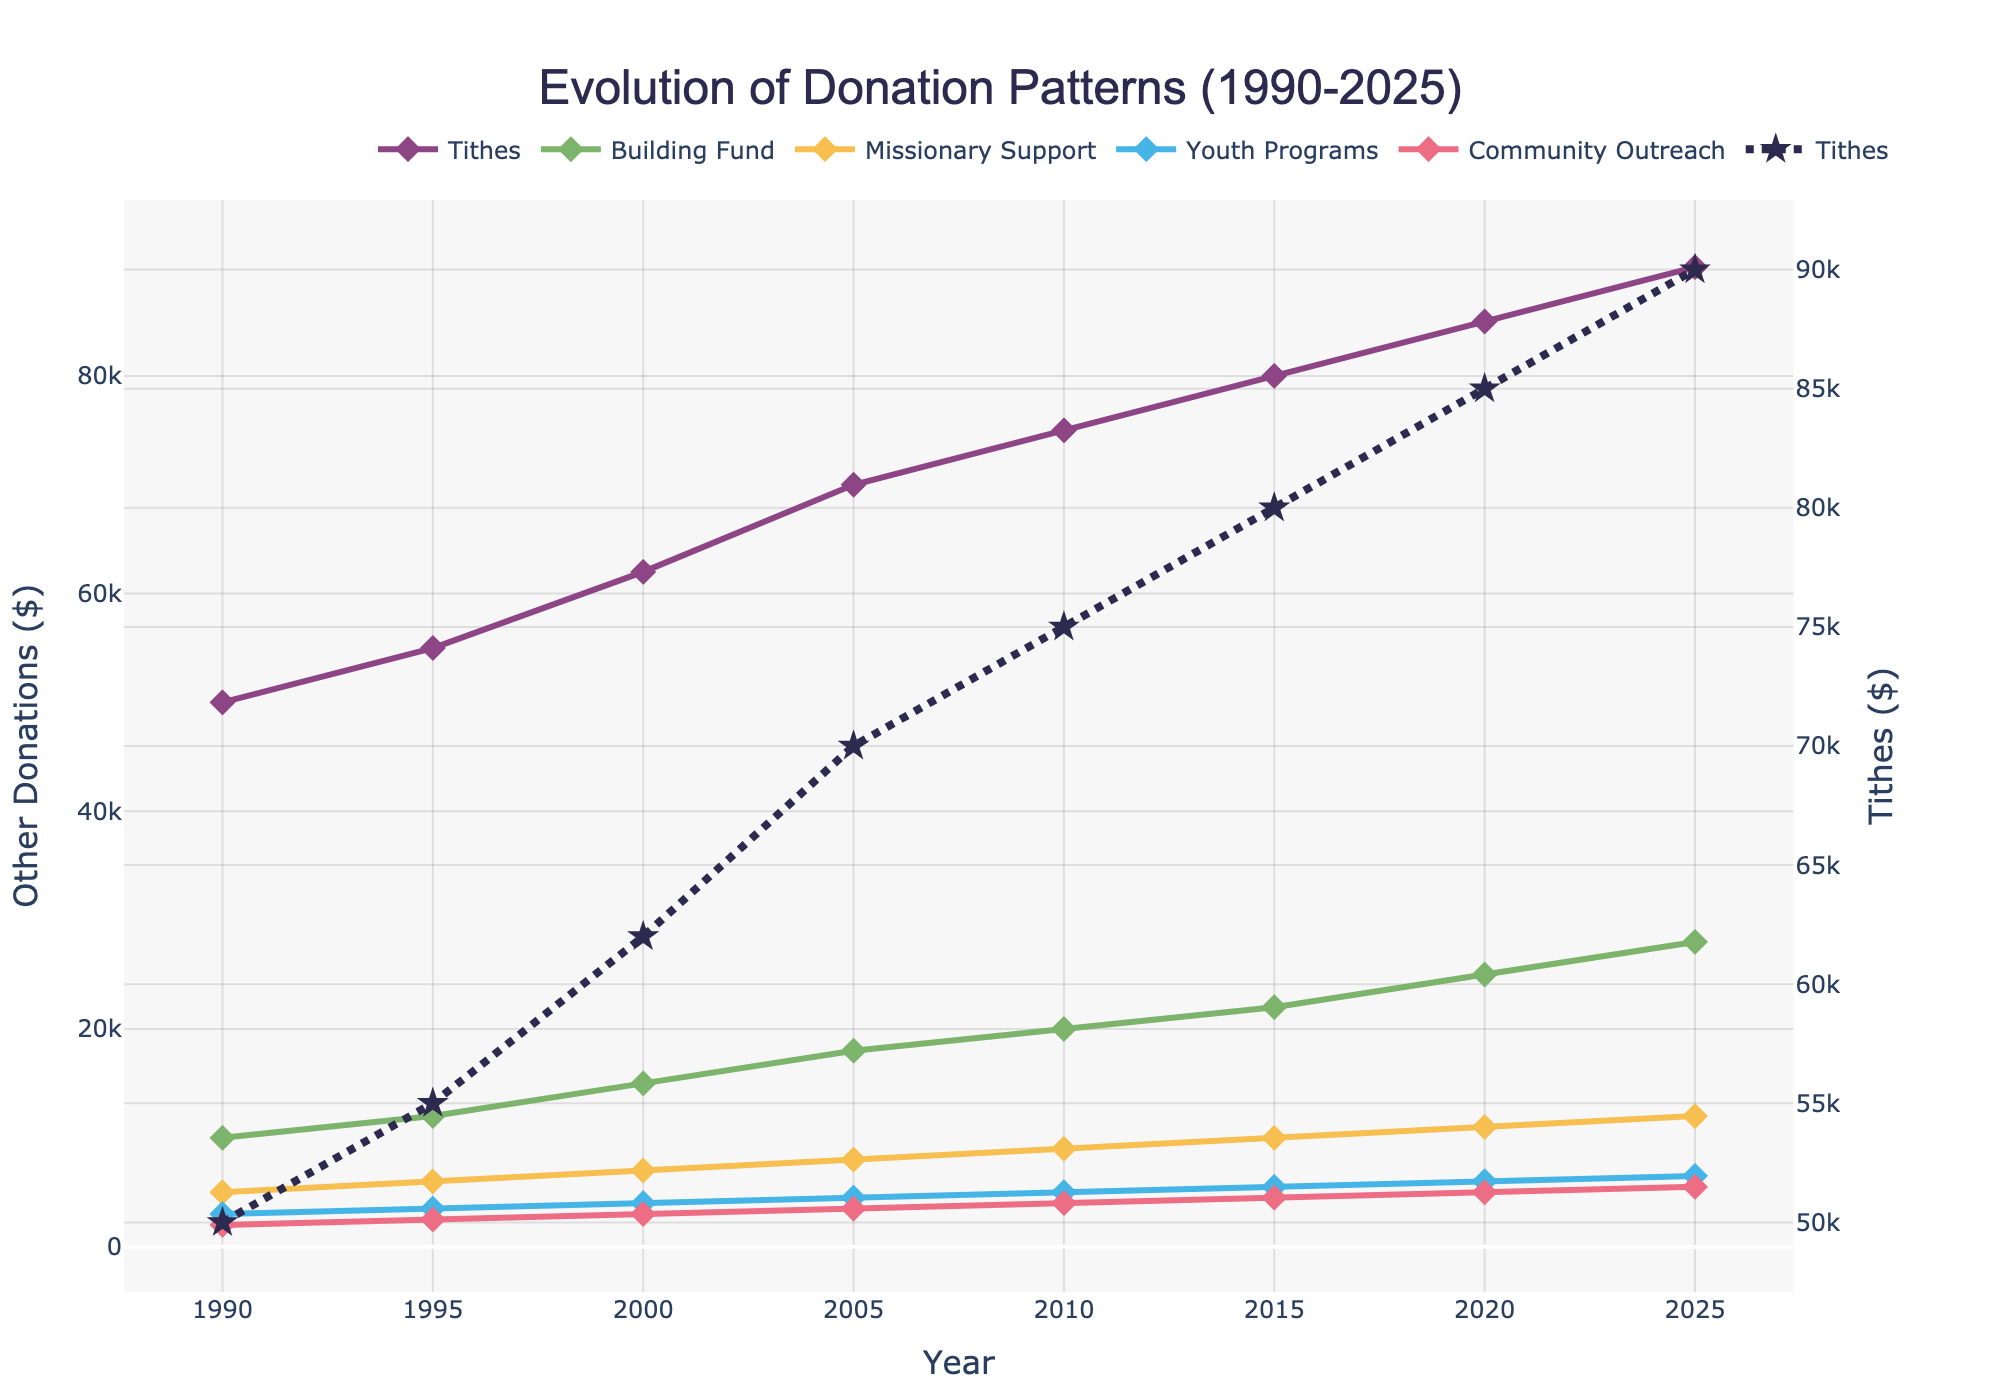What is the trend of Tithes from 1990 to 2025? To determine the trend of Tithes, observe the line representing Tithes over time in the graph. It starts at $50,000 in 1990 and increases steadily with clear growth reaching $90,000 by 2025.
Answer: Steadily increasing Which contribution category received the highest amount of donations in 2025, excluding Tithes? Check the lines showing individual donations for each category in 2025 and compare their endpoints. Building Fund has the highest value of $28,000, excluding Tithes.
Answer: Building Fund How does the growth rate of Youth Programs compare to Community Outreach from 1990 to 2025? Calculate the difference in donations from 1990 to 2025 for both categories. Youth Programs increased from $3,000 to $6,500 (an increase of $3,500), and Community Outreach from $2,000 to $5,500 (an increase of $3,500). Both categories have the same growth rate of $3,500.
Answer: Equal growth rate What was the total amount of donations in 2010 across all categories excluding Tithes? Sum the donations for Building Fund, Missionary Support, Youth Programs, and Community Outreach in 2010: $20,000 + $9,000 + $5,000 + $4,000 = $38,000.
Answer: $38,000 Which contribution category showed the most significant increase between any two consecutive periods, and what is the amount? Compare the increase in each category between consecutive periods, noting the largest change. Building Fund from 2020 ($25,000) to 2025 ($28,000) shows the largest increase of $3,000.
Answer: Building Fund, $3,000 How did donations towards Missionary Support change from 1990 to 2020? Observe the line for Missionary Support, noting the value at 1990 compared to 2020. It starts at $5,000 and increases steadily to $11,000 by 2020.
Answer: Increased by $6,000 What are the two years where the Community Outreach donations increased the most? Identify the years by observing changes in the Community Outreach trend line. The largest increase happens from 2020 ($5,000) to 2025 ($5,500).
Answer: 2020 to 2025 By how much did Building Fund donations grow between 1995 and 2000? Subtract the Building Fund value in 1995 ($12,000) from that in 2000 ($15,000) to find the growth: $15,000 - $12,000 = $3,000.
Answer: $3,000 